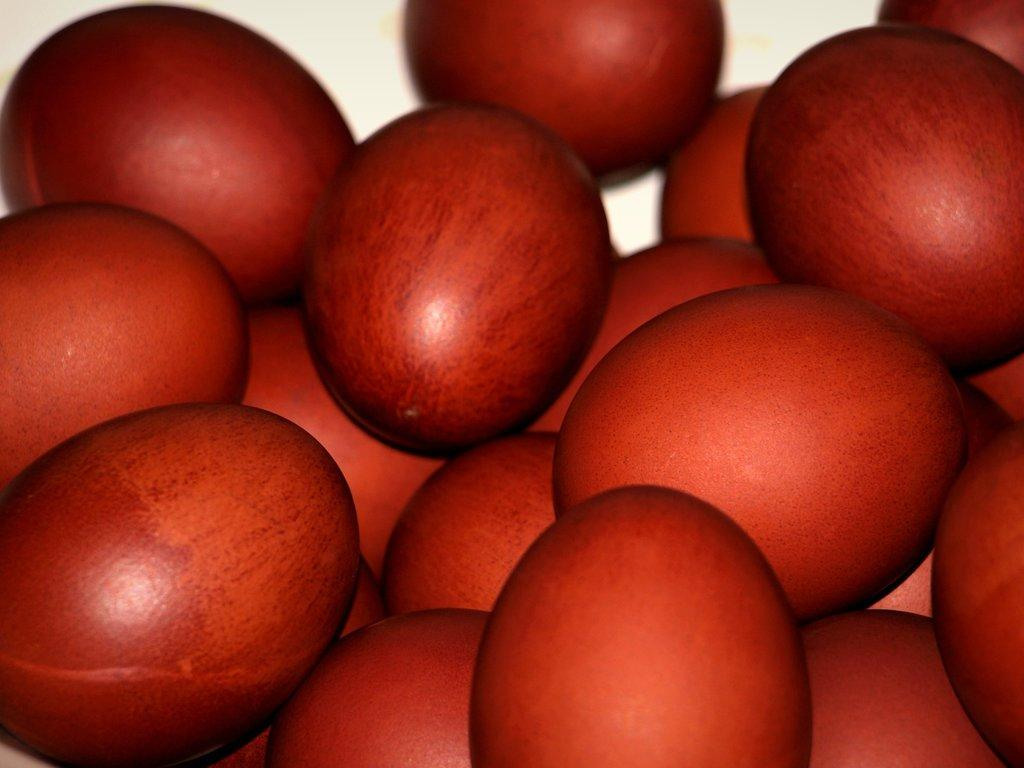What color can be observed in the objects present in the image? There are red color objects in the image. Can you tell me how many eggs are in the eggnog in the image? There is no eggnog present in the image, and therefore no eggs can be observed. What type of cap is being worn by the person in the image? There is no person or cap present in the image. 